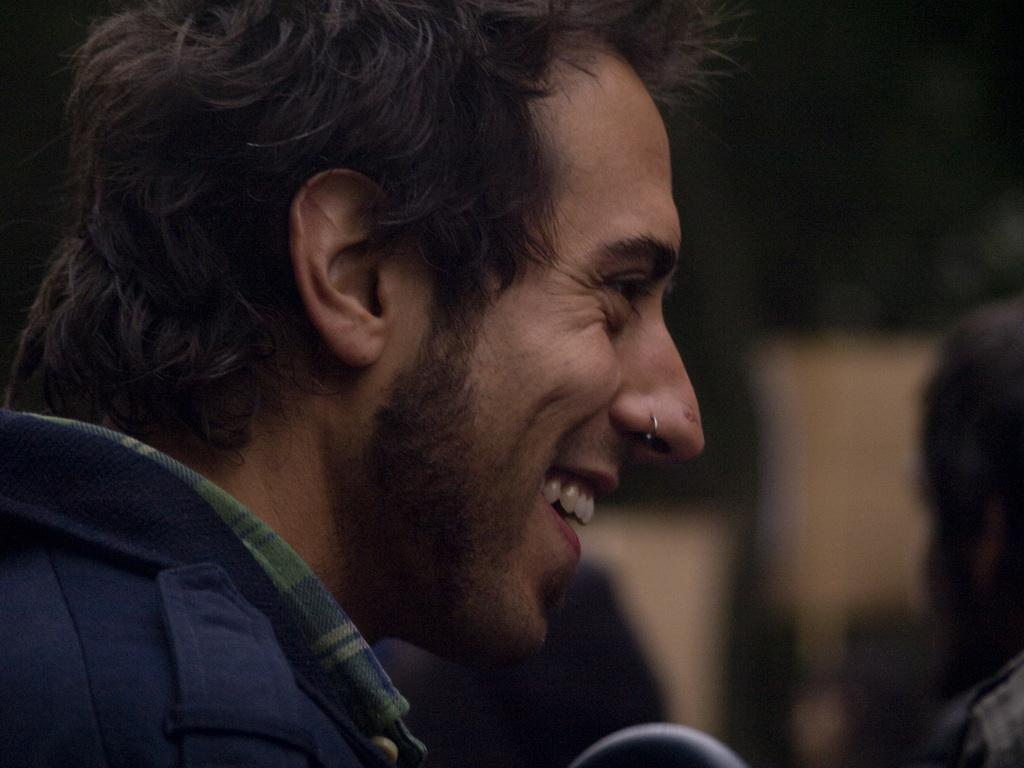Who or what is the main subject in the image? There is a person in the image. Can you describe the background of the image? The background of the image is blurred. Are there any other people visible in the image? Yes, there is another person on the right side of the image. What type of rod is being used by the person in the image? There is no rod present in the image. 